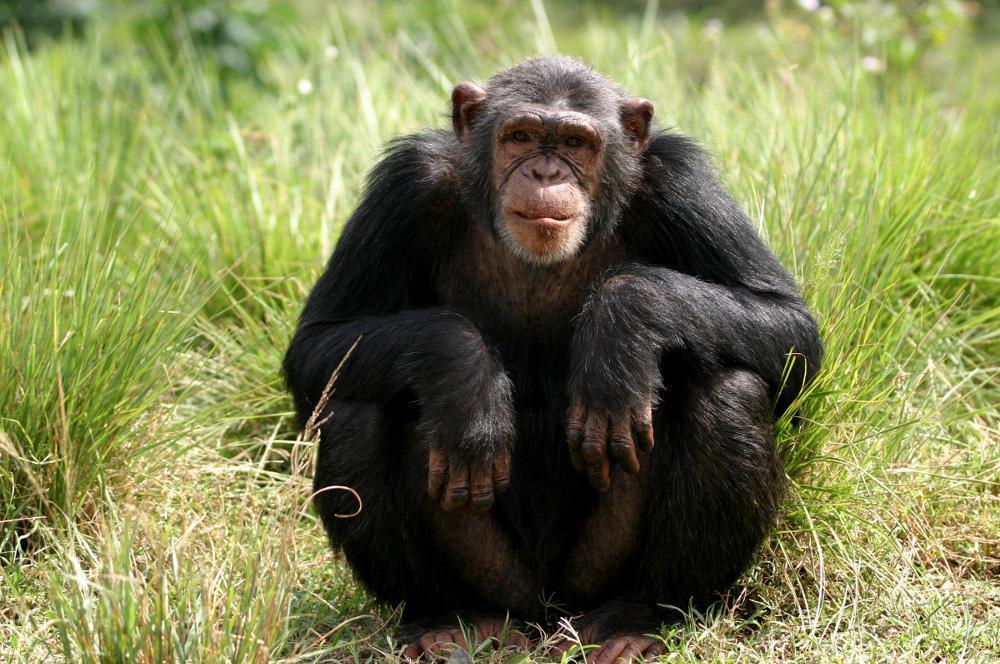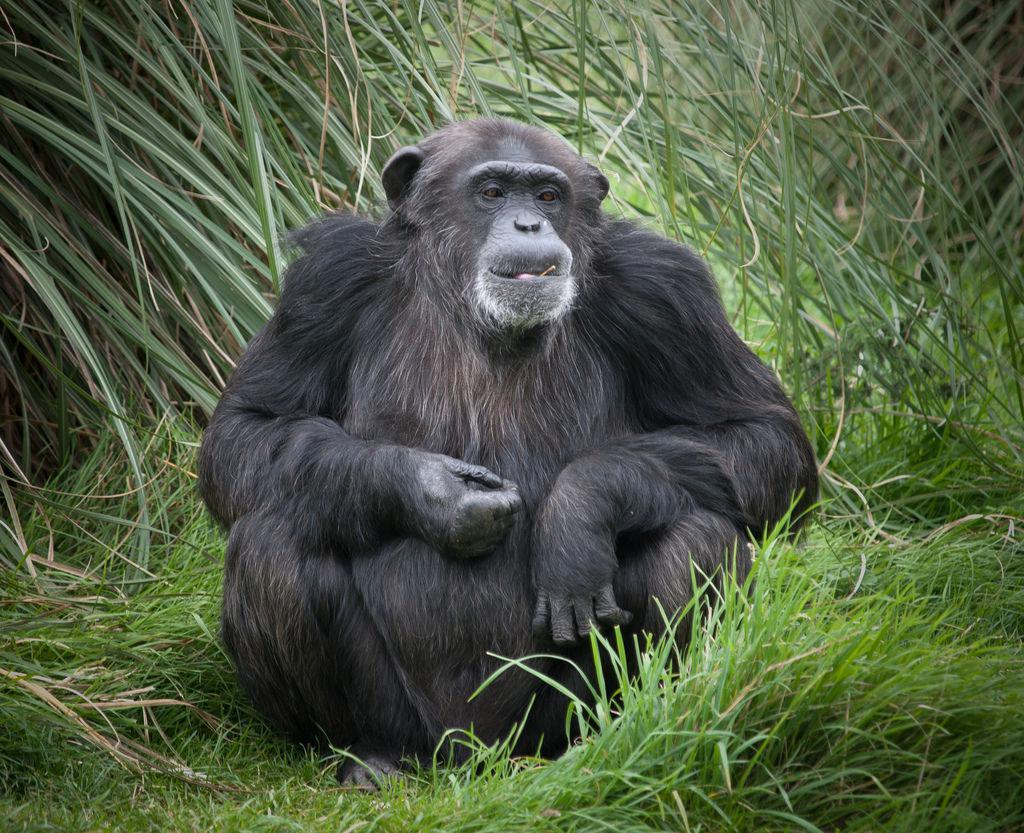The first image is the image on the left, the second image is the image on the right. Assess this claim about the two images: "There is exactly one animal in the image on the left.". Correct or not? Answer yes or no. Yes. 